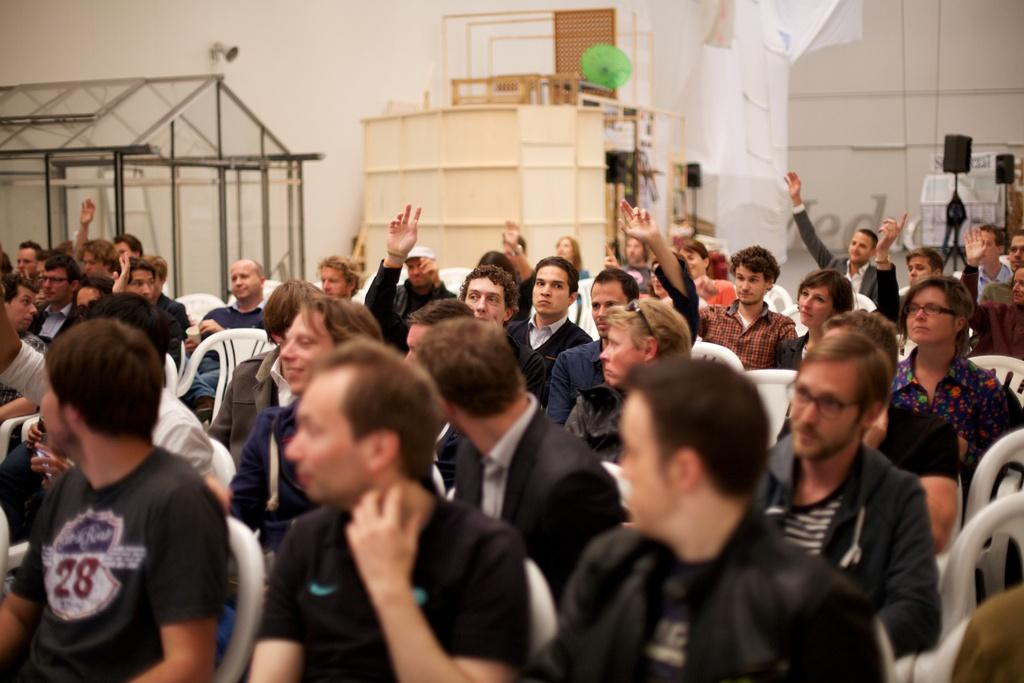What are the people in the image doing? The people in the image are sitting on chairs. What can be seen in the background of the image? There is a wall and black color stands in the background of the image. Are there any other items visible in the background? Yes, there are other items visible in the background of the image. What type of creature is creating mist in the image? There is no creature or mist present in the image. 